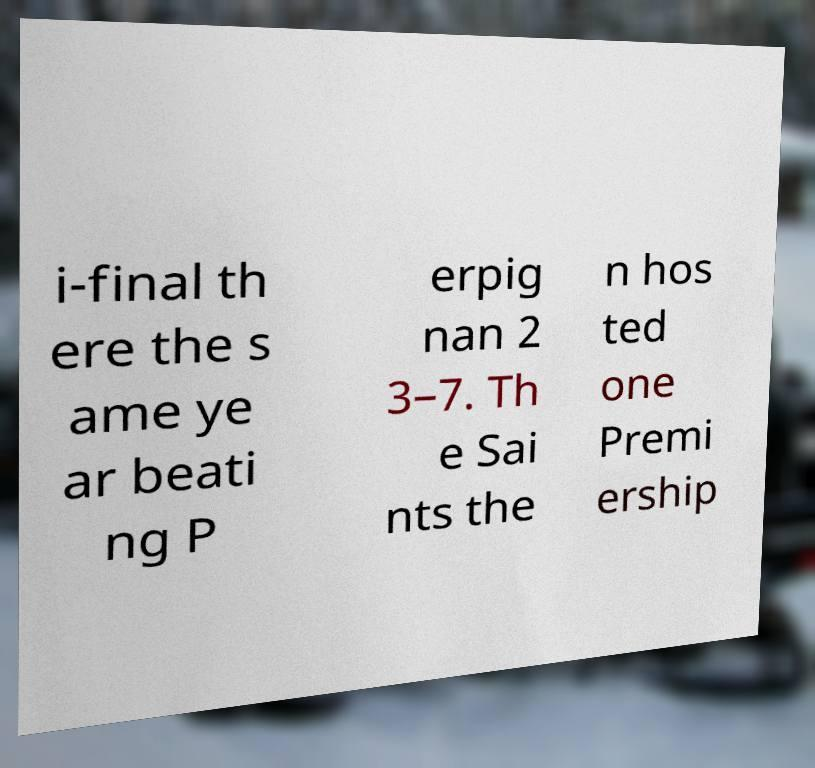Please read and relay the text visible in this image. What does it say? i-final th ere the s ame ye ar beati ng P erpig nan 2 3–7. Th e Sai nts the n hos ted one Premi ership 